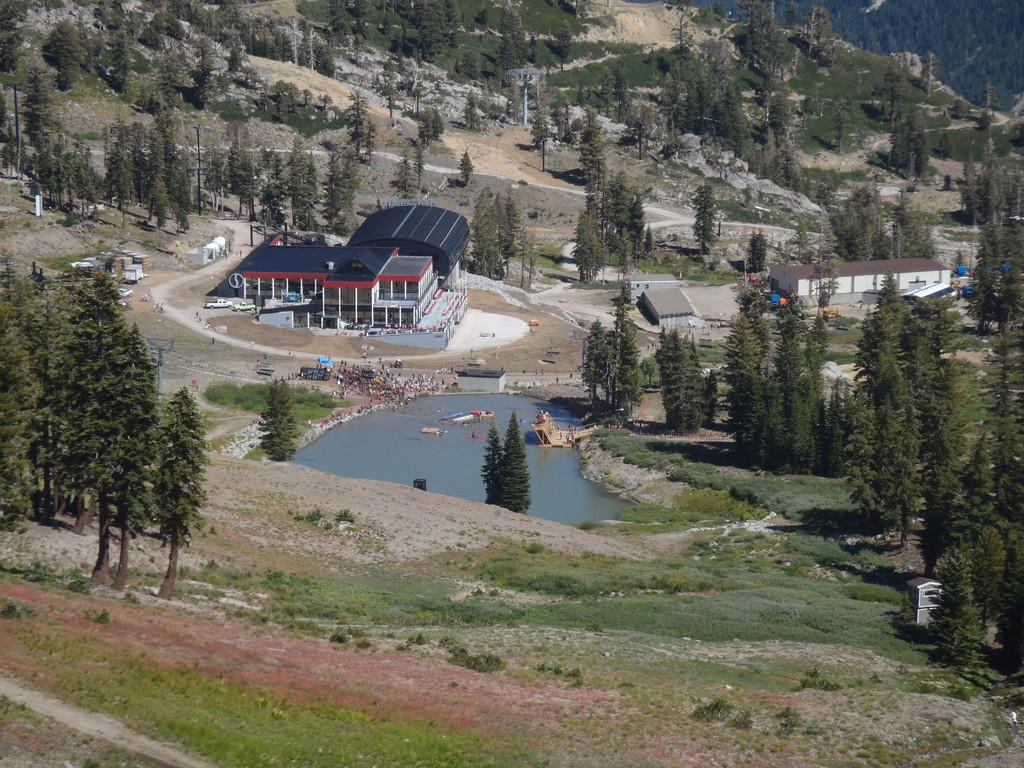What type of structure is visible in the image? There is a building in the image. What can be seen at the bottom of the image? There is water at the bottom of the image. What type of vegetation is present on the ground? Green grass is present on the ground. How many trees can be seen in the image? There are many trees in the image. Can you see a snail crawling on the cushion in the image? There is no cushion present in the image, and therefore no snail can be seen crawling on it. 